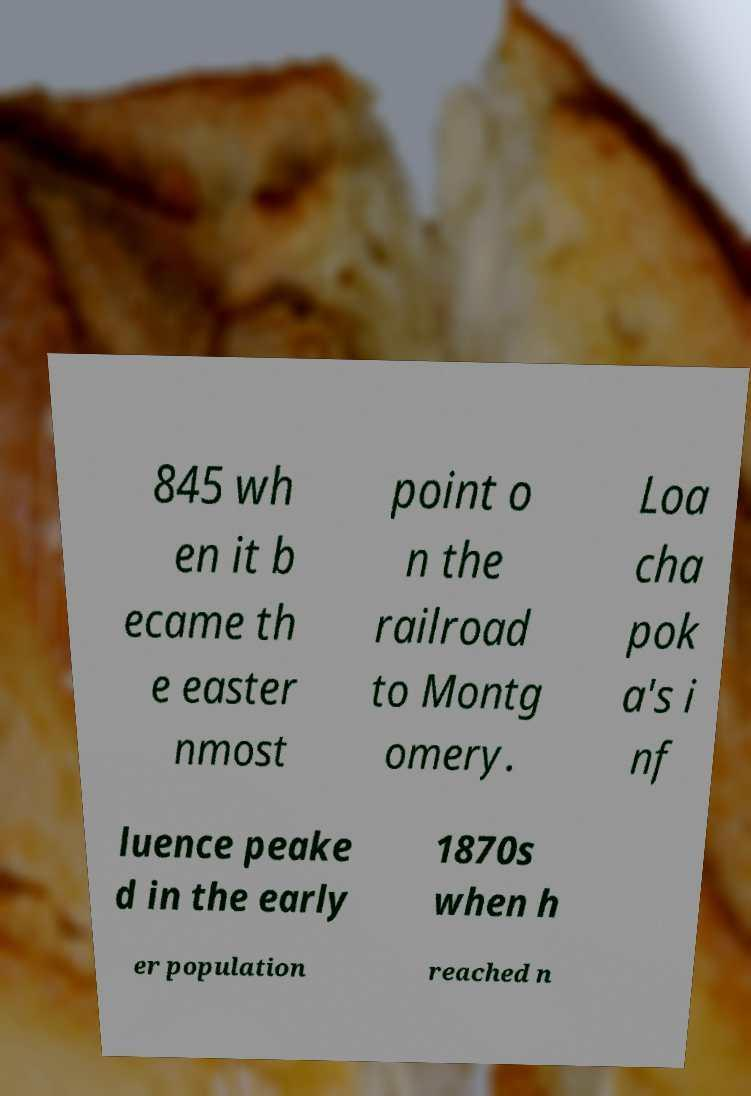For documentation purposes, I need the text within this image transcribed. Could you provide that? 845 wh en it b ecame th e easter nmost point o n the railroad to Montg omery. Loa cha pok a's i nf luence peake d in the early 1870s when h er population reached n 